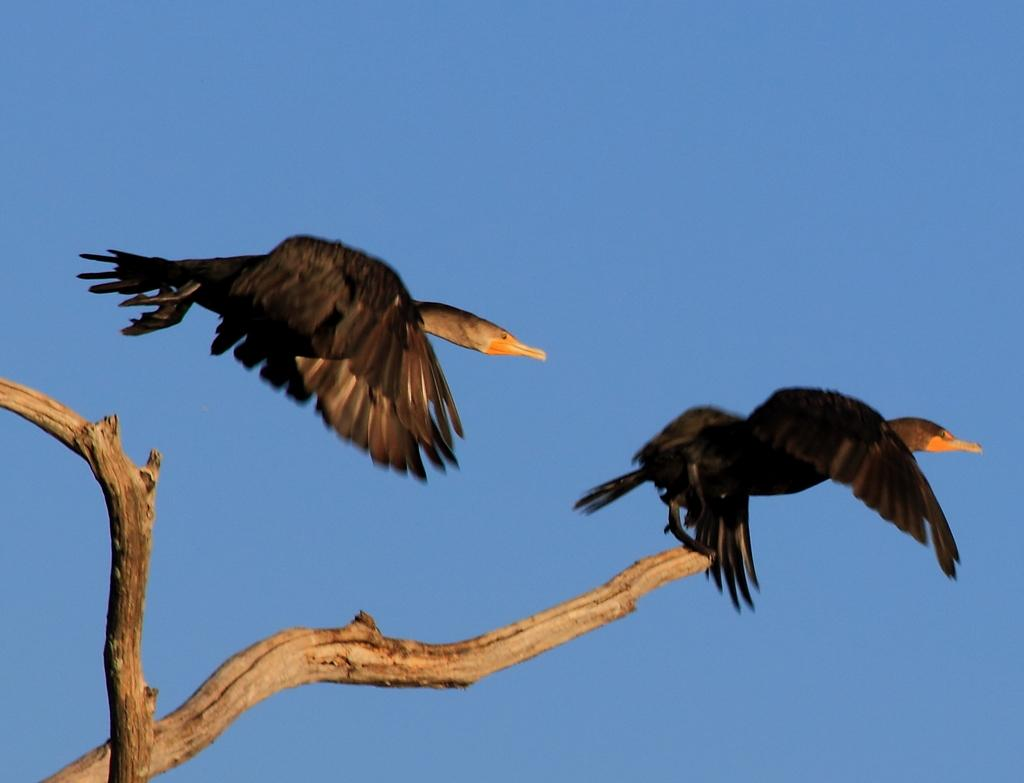What is happening with the bird in the image? There is a bird flying in the air in the image, and another bird is on a wooden branch. Can you describe the background of the image? The sky is blue in color in the image. What advertisement can be seen on the bird's wing in the image? There is no advertisement present on the bird's wing in the image. What type of weather is depicted in the image? The provided facts do not mention any specific weather conditions, so we cannot determine the weather from the image. 